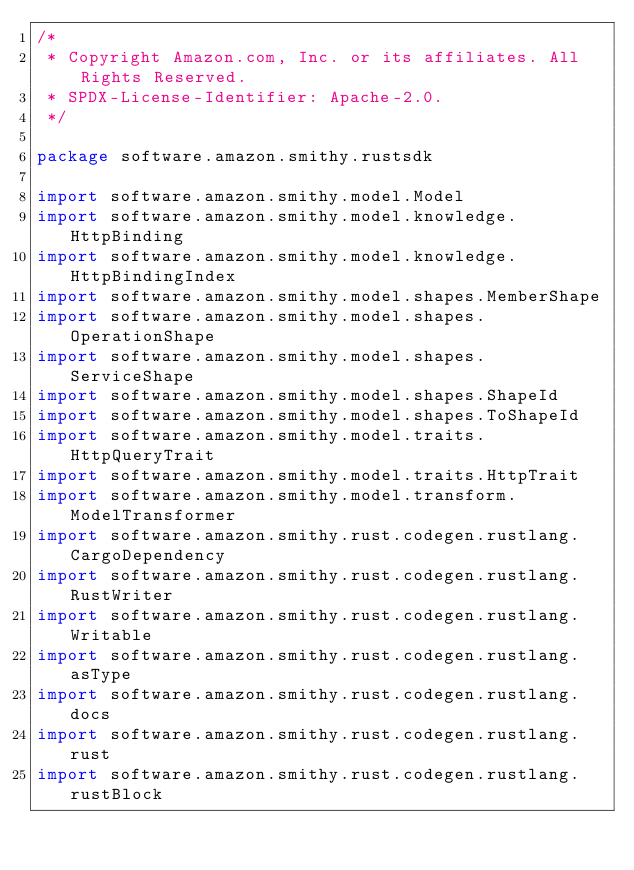Convert code to text. <code><loc_0><loc_0><loc_500><loc_500><_Kotlin_>/*
 * Copyright Amazon.com, Inc. or its affiliates. All Rights Reserved.
 * SPDX-License-Identifier: Apache-2.0.
 */

package software.amazon.smithy.rustsdk

import software.amazon.smithy.model.Model
import software.amazon.smithy.model.knowledge.HttpBinding
import software.amazon.smithy.model.knowledge.HttpBindingIndex
import software.amazon.smithy.model.shapes.MemberShape
import software.amazon.smithy.model.shapes.OperationShape
import software.amazon.smithy.model.shapes.ServiceShape
import software.amazon.smithy.model.shapes.ShapeId
import software.amazon.smithy.model.shapes.ToShapeId
import software.amazon.smithy.model.traits.HttpQueryTrait
import software.amazon.smithy.model.traits.HttpTrait
import software.amazon.smithy.model.transform.ModelTransformer
import software.amazon.smithy.rust.codegen.rustlang.CargoDependency
import software.amazon.smithy.rust.codegen.rustlang.RustWriter
import software.amazon.smithy.rust.codegen.rustlang.Writable
import software.amazon.smithy.rust.codegen.rustlang.asType
import software.amazon.smithy.rust.codegen.rustlang.docs
import software.amazon.smithy.rust.codegen.rustlang.rust
import software.amazon.smithy.rust.codegen.rustlang.rustBlock</code> 